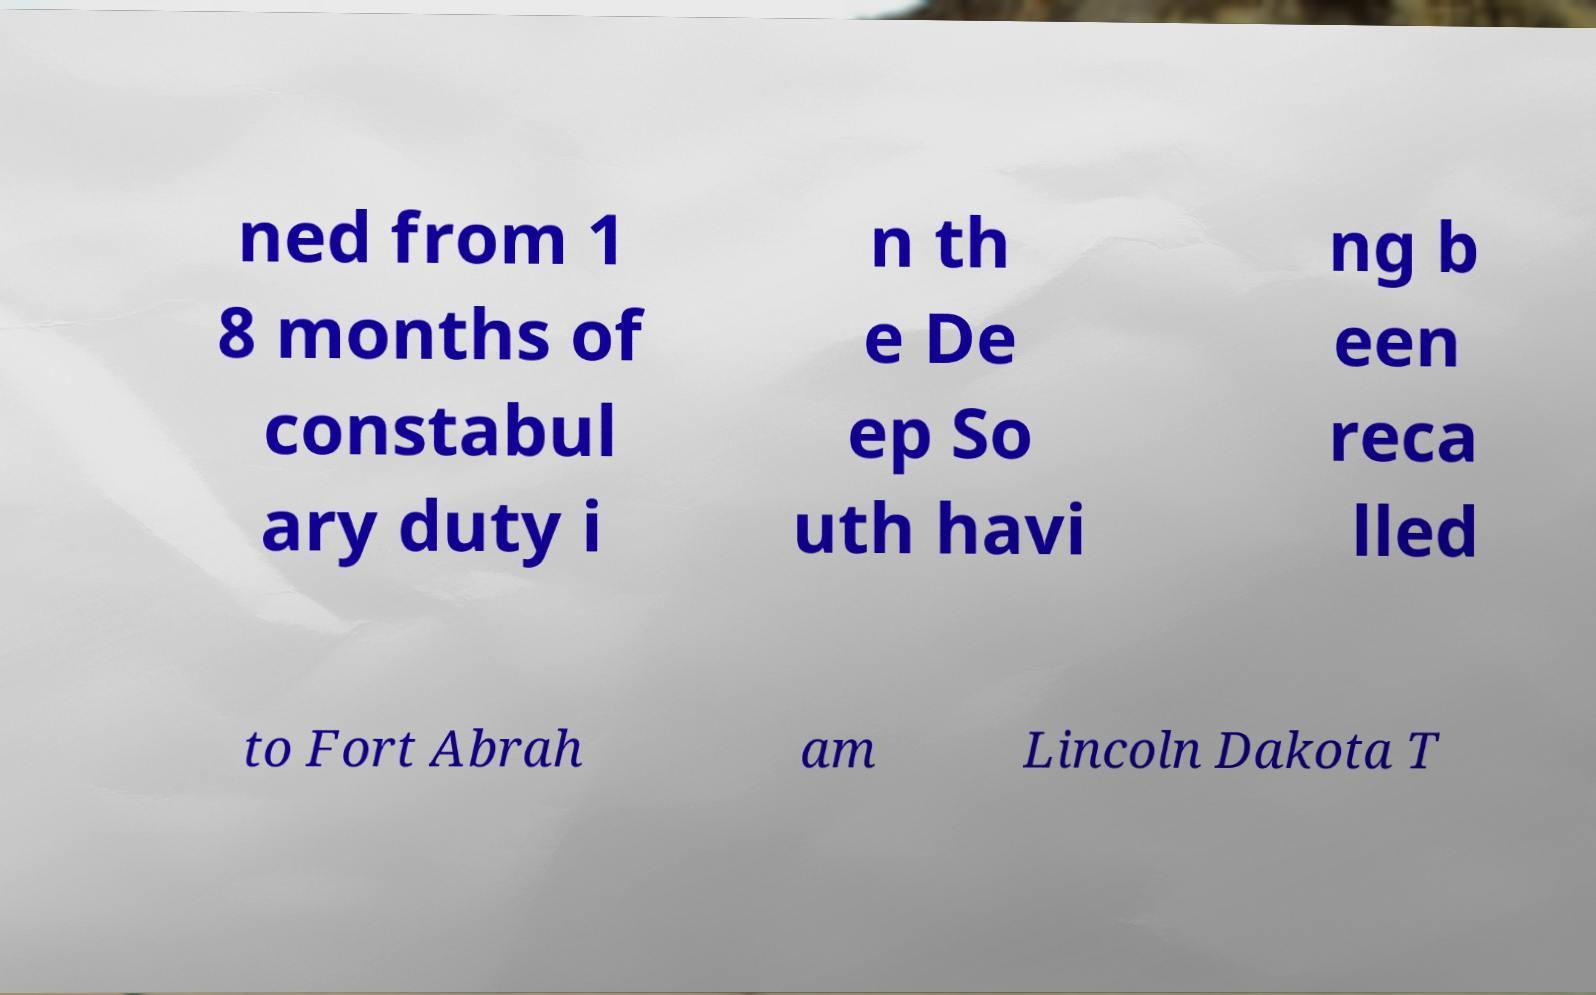What messages or text are displayed in this image? I need them in a readable, typed format. ned from 1 8 months of constabul ary duty i n th e De ep So uth havi ng b een reca lled to Fort Abrah am Lincoln Dakota T 